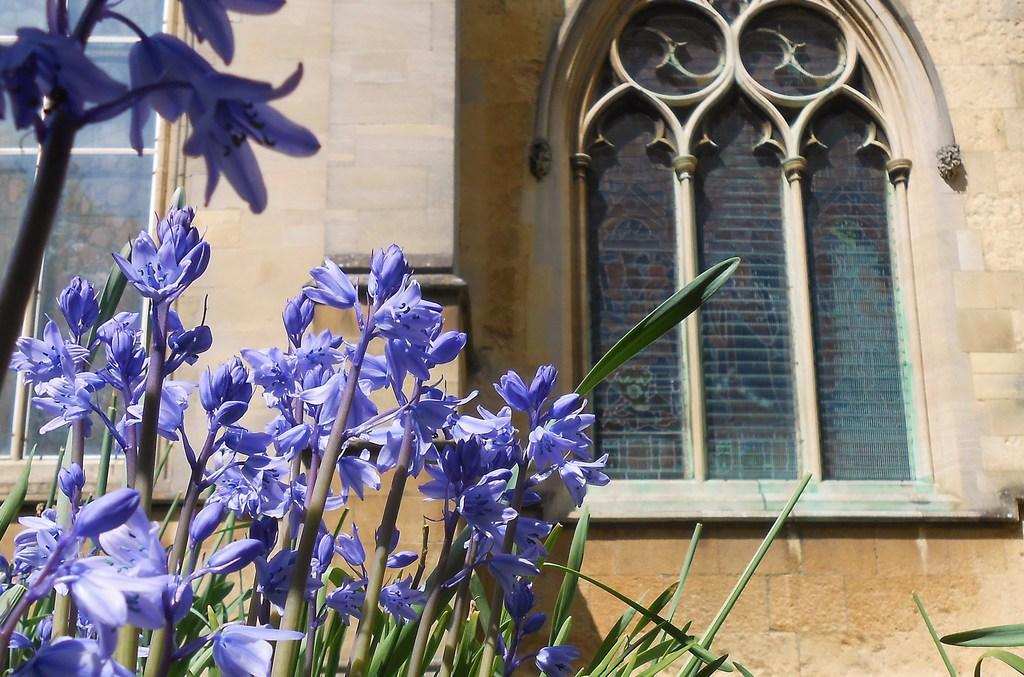What is the main structure in the center of the image? There is a building in the center of the image. What features can be observed on the building? The building has windows and walls. What type of vegetation is present at the bottom of the image? There are plants, flowers, and leaves visible at the bottom of the image. How long does it take for the milk to be consumed in the image? There is no milk present in the image, so it is not possible to determine how long it takes to be consumed. 